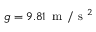<formula> <loc_0><loc_0><loc_500><loc_500>g = 9 . 8 1 \, m / s ^ { 2 }</formula> 